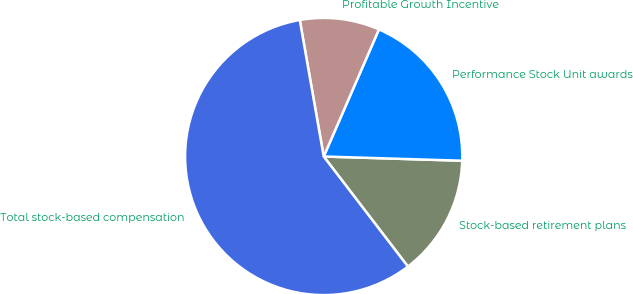Convert chart to OTSL. <chart><loc_0><loc_0><loc_500><loc_500><pie_chart><fcel>Stock-based retirement plans<fcel>Performance Stock Unit awards<fcel>Profitable Growth Incentive<fcel>Total stock-based compensation<nl><fcel>14.12%<fcel>18.96%<fcel>9.29%<fcel>57.63%<nl></chart> 